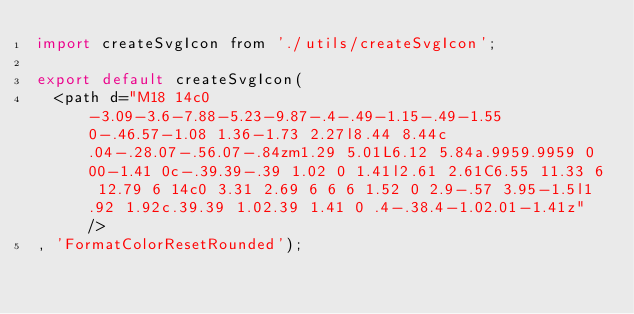Convert code to text. <code><loc_0><loc_0><loc_500><loc_500><_JavaScript_>import createSvgIcon from './utils/createSvgIcon';

export default createSvgIcon(
  <path d="M18 14c0-3.09-3.6-7.88-5.23-9.87-.4-.49-1.15-.49-1.55 0-.46.57-1.08 1.36-1.73 2.27l8.44 8.44c.04-.28.07-.56.07-.84zm1.29 5.01L6.12 5.84a.9959.9959 0 00-1.41 0c-.39.39-.39 1.02 0 1.41l2.61 2.61C6.55 11.33 6 12.79 6 14c0 3.31 2.69 6 6 6 1.52 0 2.9-.57 3.95-1.5l1.92 1.92c.39.39 1.02.39 1.41 0 .4-.38.4-1.02.01-1.41z" />
, 'FormatColorResetRounded');
</code> 